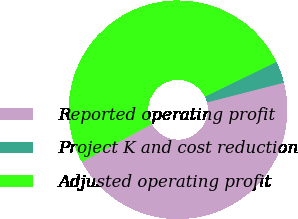Convert chart. <chart><loc_0><loc_0><loc_500><loc_500><pie_chart><fcel>Reported operating profit<fcel>Project K and cost reduction<fcel>Adjusted operating profit<nl><fcel>46.09%<fcel>3.22%<fcel>50.69%<nl></chart> 